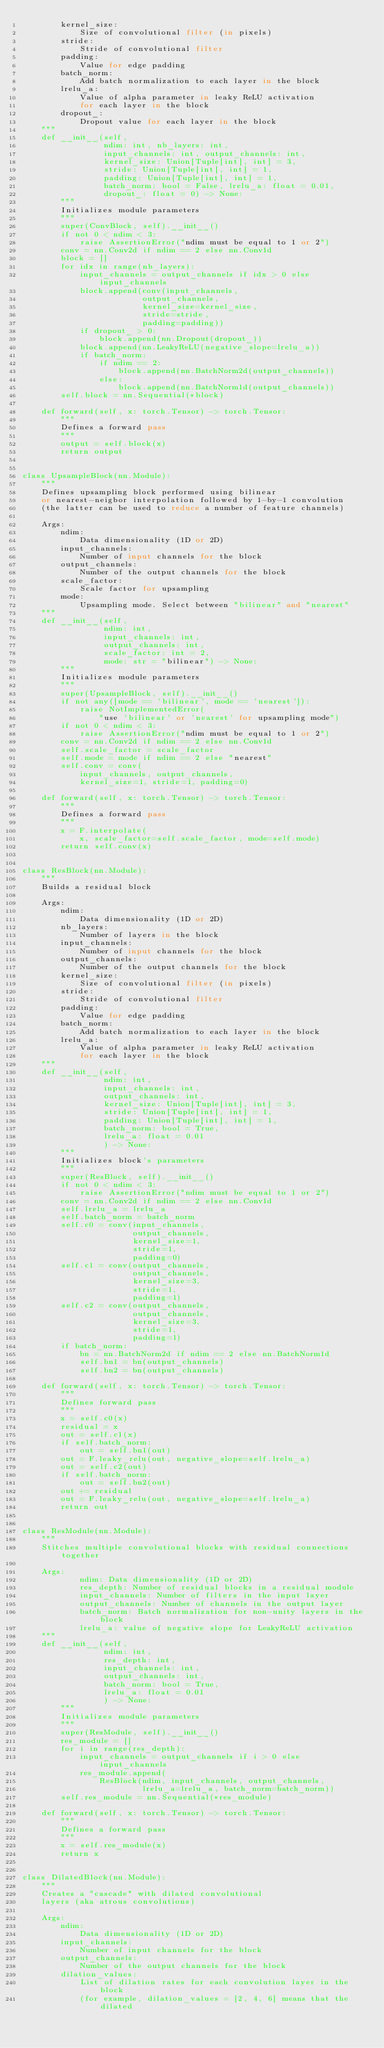Convert code to text. <code><loc_0><loc_0><loc_500><loc_500><_Python_>        kernel_size:
            Size of convolutional filter (in pixels)
        stride:
            Stride of convolutional filter
        padding:
            Value for edge padding
        batch_norm:
            Add batch normalization to each layer in the block
        lrelu_a:
            Value of alpha parameter in leaky ReLU activation
            for each layer in the block
        dropout_:
            Dropout value for each layer in the block
    """
    def __init__(self,
                 ndim: int, nb_layers: int,
                 input_channels: int, output_channels: int,
                 kernel_size: Union[Tuple[int], int] = 3,
                 stride: Union[Tuple[int], int] = 1,
                 padding: Union[Tuple[int], int] = 1,
                 batch_norm: bool = False, lrelu_a: float = 0.01,
                 dropout_: float = 0) -> None:
        """
        Initializes module parameters
        """
        super(ConvBlock, self).__init__()
        if not 0 < ndim < 3:
            raise AssertionError("ndim must be equal to 1 or 2")
        conv = nn.Conv2d if ndim == 2 else nn.Conv1d
        block = []
        for idx in range(nb_layers):
            input_channels = output_channels if idx > 0 else input_channels
            block.append(conv(input_channels,
                         output_channels,
                         kernel_size=kernel_size,
                         stride=stride,
                         padding=padding))
            if dropout_ > 0:
                block.append(nn.Dropout(dropout_))
            block.append(nn.LeakyReLU(negative_slope=lrelu_a))
            if batch_norm:
                if ndim == 2:
                    block.append(nn.BatchNorm2d(output_channels))
                else:
                    block.append(nn.BatchNorm1d(output_channels))
        self.block = nn.Sequential(*block)

    def forward(self, x: torch.Tensor) -> torch.Tensor:
        """
        Defines a forward pass
        """
        output = self.block(x)
        return output


class UpsampleBlock(nn.Module):
    """
    Defines upsampling block performed using bilinear
    or nearest-neigbor interpolation followed by 1-by-1 convolution
    (the latter can be used to reduce a number of feature channels)

    Args:
        ndim:
            Data dimensionality (1D or 2D)
        input_channels:
            Number of input channels for the block
        output_channels:
            Number of the output channels for the block
        scale_factor:
            Scale factor for upsampling
        mode:
            Upsampling mode. Select between "bilinear" and "nearest"
    """
    def __init__(self,
                 ndim: int,
                 input_channels: int,
                 output_channels: int,
                 scale_factor: int = 2,
                 mode: str = "bilinear") -> None:
        """
        Initializes module parameters
        """
        super(UpsampleBlock, self).__init__()
        if not any([mode == 'bilinear', mode == 'nearest']):
            raise NotImplementedError(
                "use 'bilinear' or 'nearest' for upsampling mode")
        if not 0 < ndim < 3:
            raise AssertionError("ndim must be equal to 1 or 2")
        conv = nn.Conv2d if ndim == 2 else nn.Conv1d
        self.scale_factor = scale_factor
        self.mode = mode if ndim == 2 else "nearest"
        self.conv = conv(
            input_channels, output_channels,
            kernel_size=1, stride=1, padding=0)

    def forward(self, x: torch.Tensor) -> torch.Tensor:
        """
        Defines a forward pass
        """
        x = F.interpolate(
            x, scale_factor=self.scale_factor, mode=self.mode)
        return self.conv(x)


class ResBlock(nn.Module):
    """
    Builds a residual block

    Args:
        ndim:
            Data dimensionality (1D or 2D)
        nb_layers:
            Number of layers in the block
        input_channels:
            Number of input channels for the block
        output_channels:
            Number of the output channels for the block
        kernel_size:
            Size of convolutional filter (in pixels)
        stride:
            Stride of convolutional filter
        padding:
            Value for edge padding
        batch_norm:
            Add batch normalization to each layer in the block
        lrelu_a:
            Value of alpha parameter in leaky ReLU activation
            for each layer in the block
    """
    def __init__(self,
                 ndim: int,
                 input_channels: int,
                 output_channels: int,
                 kernel_size: Union[Tuple[int], int] = 3,
                 stride: Union[Tuple[int], int] = 1,
                 padding: Union[Tuple[int], int] = 1,
                 batch_norm: bool = True,
                 lrelu_a: float = 0.01
                 ) -> None:
        """
        Initializes block's parameters
        """
        super(ResBlock, self).__init__()
        if not 0 < ndim < 3:
            raise AssertionError("ndim must be equal to 1 or 2")
        conv = nn.Conv2d if ndim == 2 else nn.Conv1d
        self.lrelu_a = lrelu_a
        self.batch_norm = batch_norm
        self.c0 = conv(input_channels,
                       output_channels,
                       kernel_size=1,
                       stride=1,
                       padding=0)
        self.c1 = conv(output_channels,
                       output_channels,
                       kernel_size=3,
                       stride=1,
                       padding=1)
        self.c2 = conv(output_channels,
                       output_channels,
                       kernel_size=3,
                       stride=1,
                       padding=1)
        if batch_norm:
            bn = nn.BatchNorm2d if ndim == 2 else nn.BatchNorm1d
            self.bn1 = bn(output_channels)
            self.bn2 = bn(output_channels)

    def forward(self, x: torch.Tensor) -> torch.Tensor:
        """
        Defines forward pass
        """
        x = self.c0(x)
        residual = x
        out = self.c1(x)
        if self.batch_norm:
            out = self.bn1(out)
        out = F.leaky_relu(out, negative_slope=self.lrelu_a)
        out = self.c2(out)
        if self.batch_norm:
            out = self.bn2(out)
        out += residual
        out = F.leaky_relu(out, negative_slope=self.lrelu_a)
        return out


class ResModule(nn.Module):
    """
    Stitches multiple convolutional blocks with residual connections together

    Args:
            ndim: Data dimensionality (1D or 2D)
            res_depth: Number of residual blocks in a residual module
            input_channels: Number of filters in the input layer
            output_channels: Number of channels in the output layer
            batch_norm: Batch normalization for non-unity layers in the block
            lrelu_a: value of negative slope for LeakyReLU activation
    """
    def __init__(self,
                 ndim: int,
                 res_depth: int,
                 input_channels: int,
                 output_channels: int,
                 batch_norm: bool = True,
                 lrelu_a: float = 0.01
                 ) -> None:
        """
        Initializes module parameters
        """
        super(ResModule, self).__init__()
        res_module = []
        for i in range(res_depth):
            input_channels = output_channels if i > 0 else input_channels
            res_module.append(
                ResBlock(ndim, input_channels, output_channels,
                         lrelu_a=lrelu_a, batch_norm=batch_norm))
        self.res_module = nn.Sequential(*res_module)

    def forward(self, x: torch.Tensor) -> torch.Tensor:
        """
        Defines a forward pass
        """
        x = self.res_module(x)
        return x


class DilatedBlock(nn.Module):
    """
    Creates a "cascade" with dilated convolutional
    layers (aka atrous convolutions)

    Args:
        ndim:
            Data dimensionality (1D or 2D)
        input_channels:
            Number of input channels for the block
        output_channels:
            Number of the output channels for the block
        dilation_values:
            List of dilation rates for each convolution layer in the block
            (for example, dilation_values = [2, 4, 6] means that the dilated</code> 